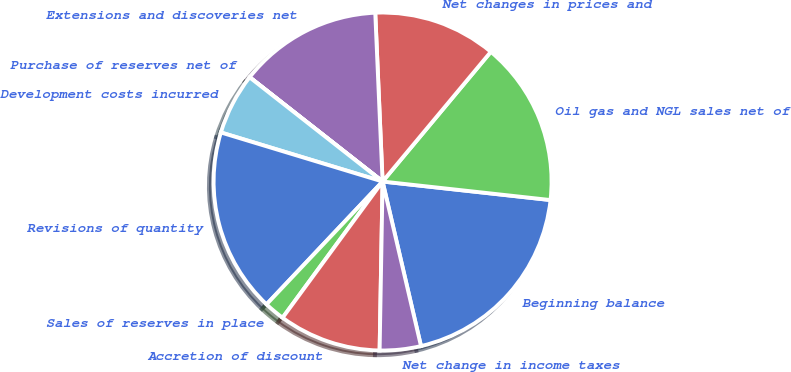<chart> <loc_0><loc_0><loc_500><loc_500><pie_chart><fcel>Beginning balance<fcel>Oil gas and NGL sales net of<fcel>Net changes in prices and<fcel>Extensions and discoveries net<fcel>Purchase of reserves net of<fcel>Development costs incurred<fcel>Revisions of quantity<fcel>Sales of reserves in place<fcel>Accretion of discount<fcel>Net change in income taxes<nl><fcel>19.6%<fcel>15.68%<fcel>11.76%<fcel>13.72%<fcel>0.01%<fcel>5.89%<fcel>17.64%<fcel>1.97%<fcel>9.8%<fcel>3.93%<nl></chart> 